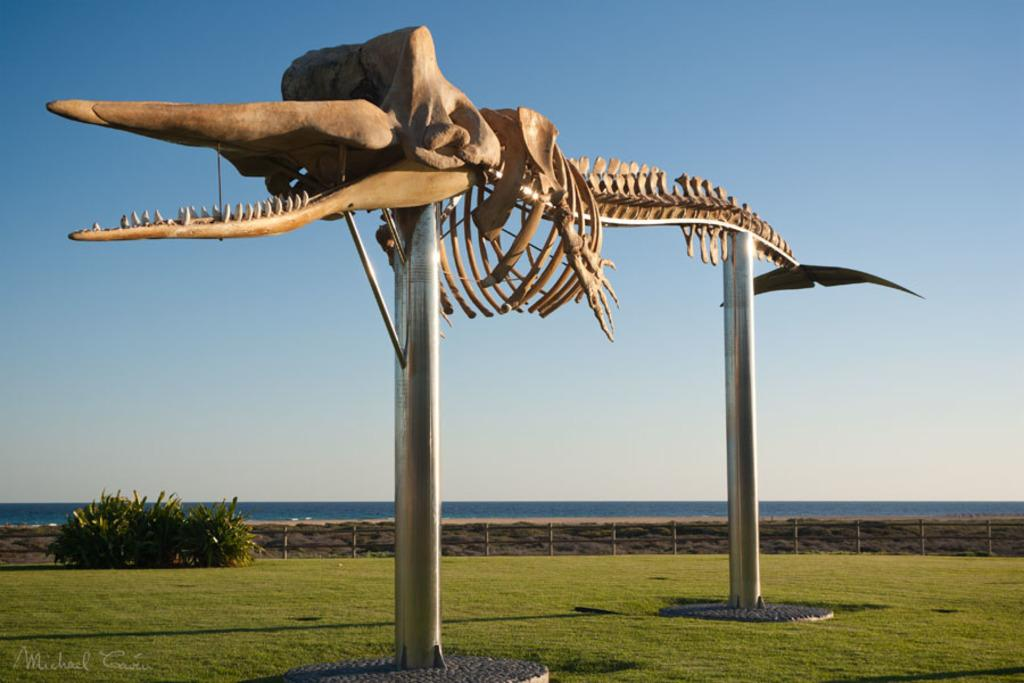What is the main subject of the image? The main subject of the image is a dinosaur skeleton on rods. What type of environment is depicted in the image? The image shows grassland at the bottom side. What color is the orange in the image? There is no orange present in the image. 